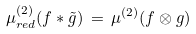<formula> <loc_0><loc_0><loc_500><loc_500>\mu ^ { ( 2 ) } _ { r e d } ( f * \tilde { g } ) \, = \, \mu ^ { ( 2 ) } ( f \otimes g )</formula> 